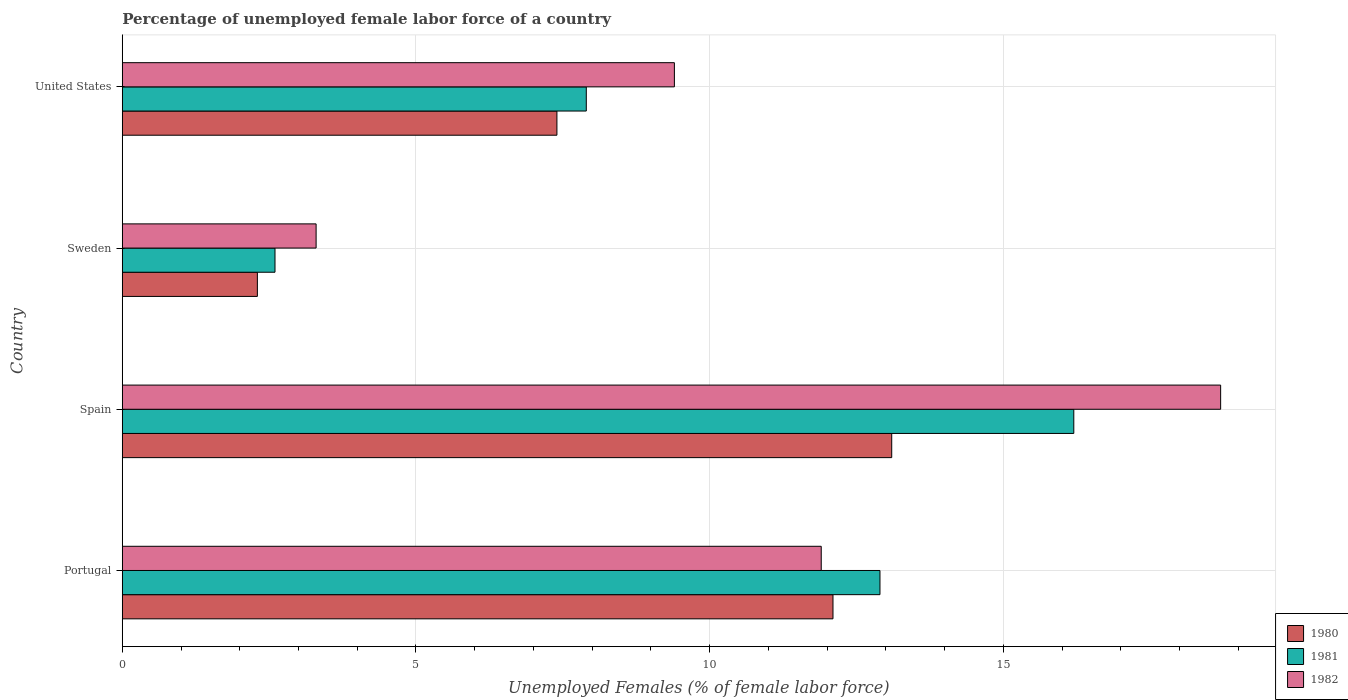Are the number of bars on each tick of the Y-axis equal?
Offer a very short reply. Yes. How many bars are there on the 4th tick from the top?
Ensure brevity in your answer.  3. What is the label of the 3rd group of bars from the top?
Provide a short and direct response. Spain. In how many cases, is the number of bars for a given country not equal to the number of legend labels?
Offer a very short reply. 0. What is the percentage of unemployed female labor force in 1980 in Portugal?
Offer a terse response. 12.1. Across all countries, what is the maximum percentage of unemployed female labor force in 1981?
Ensure brevity in your answer.  16.2. Across all countries, what is the minimum percentage of unemployed female labor force in 1981?
Provide a short and direct response. 2.6. In which country was the percentage of unemployed female labor force in 1980 maximum?
Offer a very short reply. Spain. What is the total percentage of unemployed female labor force in 1980 in the graph?
Your response must be concise. 34.9. What is the difference between the percentage of unemployed female labor force in 1981 in Portugal and that in Sweden?
Keep it short and to the point. 10.3. What is the difference between the percentage of unemployed female labor force in 1981 in Spain and the percentage of unemployed female labor force in 1982 in Portugal?
Keep it short and to the point. 4.3. What is the average percentage of unemployed female labor force in 1982 per country?
Make the answer very short. 10.82. What is the difference between the percentage of unemployed female labor force in 1982 and percentage of unemployed female labor force in 1981 in United States?
Keep it short and to the point. 1.5. What is the ratio of the percentage of unemployed female labor force in 1981 in Portugal to that in United States?
Ensure brevity in your answer.  1.63. What is the difference between the highest and the second highest percentage of unemployed female labor force in 1981?
Offer a very short reply. 3.3. What is the difference between the highest and the lowest percentage of unemployed female labor force in 1981?
Provide a short and direct response. 13.6. In how many countries, is the percentage of unemployed female labor force in 1981 greater than the average percentage of unemployed female labor force in 1981 taken over all countries?
Ensure brevity in your answer.  2. Is it the case that in every country, the sum of the percentage of unemployed female labor force in 1981 and percentage of unemployed female labor force in 1982 is greater than the percentage of unemployed female labor force in 1980?
Provide a succinct answer. Yes. How many bars are there?
Provide a short and direct response. 12. Does the graph contain any zero values?
Provide a succinct answer. No. Does the graph contain grids?
Your response must be concise. Yes. How many legend labels are there?
Give a very brief answer. 3. What is the title of the graph?
Offer a very short reply. Percentage of unemployed female labor force of a country. Does "1969" appear as one of the legend labels in the graph?
Your response must be concise. No. What is the label or title of the X-axis?
Offer a terse response. Unemployed Females (% of female labor force). What is the Unemployed Females (% of female labor force) of 1980 in Portugal?
Keep it short and to the point. 12.1. What is the Unemployed Females (% of female labor force) of 1981 in Portugal?
Your answer should be compact. 12.9. What is the Unemployed Females (% of female labor force) in 1982 in Portugal?
Offer a very short reply. 11.9. What is the Unemployed Females (% of female labor force) of 1980 in Spain?
Keep it short and to the point. 13.1. What is the Unemployed Females (% of female labor force) of 1981 in Spain?
Provide a short and direct response. 16.2. What is the Unemployed Females (% of female labor force) in 1982 in Spain?
Provide a succinct answer. 18.7. What is the Unemployed Females (% of female labor force) of 1980 in Sweden?
Provide a short and direct response. 2.3. What is the Unemployed Females (% of female labor force) of 1981 in Sweden?
Give a very brief answer. 2.6. What is the Unemployed Females (% of female labor force) in 1982 in Sweden?
Your answer should be very brief. 3.3. What is the Unemployed Females (% of female labor force) of 1980 in United States?
Your response must be concise. 7.4. What is the Unemployed Females (% of female labor force) in 1981 in United States?
Make the answer very short. 7.9. What is the Unemployed Females (% of female labor force) in 1982 in United States?
Provide a short and direct response. 9.4. Across all countries, what is the maximum Unemployed Females (% of female labor force) in 1980?
Make the answer very short. 13.1. Across all countries, what is the maximum Unemployed Females (% of female labor force) of 1981?
Give a very brief answer. 16.2. Across all countries, what is the maximum Unemployed Females (% of female labor force) in 1982?
Provide a short and direct response. 18.7. Across all countries, what is the minimum Unemployed Females (% of female labor force) in 1980?
Keep it short and to the point. 2.3. Across all countries, what is the minimum Unemployed Females (% of female labor force) in 1981?
Make the answer very short. 2.6. Across all countries, what is the minimum Unemployed Females (% of female labor force) in 1982?
Offer a very short reply. 3.3. What is the total Unemployed Females (% of female labor force) of 1980 in the graph?
Ensure brevity in your answer.  34.9. What is the total Unemployed Females (% of female labor force) of 1981 in the graph?
Offer a terse response. 39.6. What is the total Unemployed Females (% of female labor force) of 1982 in the graph?
Provide a succinct answer. 43.3. What is the difference between the Unemployed Females (% of female labor force) in 1980 in Portugal and that in Spain?
Your answer should be very brief. -1. What is the difference between the Unemployed Females (% of female labor force) in 1981 in Portugal and that in Spain?
Your answer should be very brief. -3.3. What is the difference between the Unemployed Females (% of female labor force) in 1981 in Portugal and that in Sweden?
Give a very brief answer. 10.3. What is the difference between the Unemployed Females (% of female labor force) of 1980 in Portugal and that in United States?
Make the answer very short. 4.7. What is the difference between the Unemployed Females (% of female labor force) of 1982 in Portugal and that in United States?
Offer a terse response. 2.5. What is the difference between the Unemployed Females (% of female labor force) in 1981 in Spain and that in Sweden?
Your answer should be compact. 13.6. What is the difference between the Unemployed Females (% of female labor force) in 1982 in Spain and that in Sweden?
Keep it short and to the point. 15.4. What is the difference between the Unemployed Females (% of female labor force) in 1980 in Spain and that in United States?
Offer a terse response. 5.7. What is the difference between the Unemployed Females (% of female labor force) in 1980 in Sweden and that in United States?
Ensure brevity in your answer.  -5.1. What is the difference between the Unemployed Females (% of female labor force) in 1980 in Portugal and the Unemployed Females (% of female labor force) in 1981 in Spain?
Ensure brevity in your answer.  -4.1. What is the difference between the Unemployed Females (% of female labor force) in 1980 in Portugal and the Unemployed Females (% of female labor force) in 1982 in Spain?
Give a very brief answer. -6.6. What is the difference between the Unemployed Females (% of female labor force) of 1981 in Portugal and the Unemployed Females (% of female labor force) of 1982 in Spain?
Provide a succinct answer. -5.8. What is the difference between the Unemployed Females (% of female labor force) of 1980 in Portugal and the Unemployed Females (% of female labor force) of 1982 in Sweden?
Offer a very short reply. 8.8. What is the difference between the Unemployed Females (% of female labor force) in 1981 in Portugal and the Unemployed Females (% of female labor force) in 1982 in Sweden?
Ensure brevity in your answer.  9.6. What is the difference between the Unemployed Females (% of female labor force) in 1980 in Portugal and the Unemployed Females (% of female labor force) in 1981 in United States?
Provide a short and direct response. 4.2. What is the difference between the Unemployed Females (% of female labor force) in 1981 in Portugal and the Unemployed Females (% of female labor force) in 1982 in United States?
Give a very brief answer. 3.5. What is the difference between the Unemployed Females (% of female labor force) of 1980 in Spain and the Unemployed Females (% of female labor force) of 1981 in Sweden?
Offer a very short reply. 10.5. What is the difference between the Unemployed Females (% of female labor force) of 1980 in Spain and the Unemployed Females (% of female labor force) of 1982 in Sweden?
Your answer should be compact. 9.8. What is the difference between the Unemployed Females (% of female labor force) in 1981 in Sweden and the Unemployed Females (% of female labor force) in 1982 in United States?
Make the answer very short. -6.8. What is the average Unemployed Females (% of female labor force) of 1980 per country?
Your answer should be very brief. 8.72. What is the average Unemployed Females (% of female labor force) in 1981 per country?
Keep it short and to the point. 9.9. What is the average Unemployed Females (% of female labor force) in 1982 per country?
Ensure brevity in your answer.  10.82. What is the difference between the Unemployed Females (% of female labor force) in 1981 and Unemployed Females (% of female labor force) in 1982 in Portugal?
Your response must be concise. 1. What is the difference between the Unemployed Females (% of female labor force) of 1980 and Unemployed Females (% of female labor force) of 1981 in Spain?
Offer a very short reply. -3.1. What is the difference between the Unemployed Females (% of female labor force) in 1980 and Unemployed Females (% of female labor force) in 1982 in Spain?
Give a very brief answer. -5.6. What is the difference between the Unemployed Females (% of female labor force) in 1980 and Unemployed Females (% of female labor force) in 1981 in Sweden?
Offer a very short reply. -0.3. What is the difference between the Unemployed Females (% of female labor force) in 1980 and Unemployed Females (% of female labor force) in 1982 in Sweden?
Ensure brevity in your answer.  -1. What is the difference between the Unemployed Females (% of female labor force) in 1981 and Unemployed Females (% of female labor force) in 1982 in Sweden?
Your response must be concise. -0.7. What is the difference between the Unemployed Females (% of female labor force) in 1980 and Unemployed Females (% of female labor force) in 1982 in United States?
Offer a very short reply. -2. What is the ratio of the Unemployed Females (% of female labor force) of 1980 in Portugal to that in Spain?
Your answer should be very brief. 0.92. What is the ratio of the Unemployed Females (% of female labor force) in 1981 in Portugal to that in Spain?
Your response must be concise. 0.8. What is the ratio of the Unemployed Females (% of female labor force) in 1982 in Portugal to that in Spain?
Your answer should be compact. 0.64. What is the ratio of the Unemployed Females (% of female labor force) in 1980 in Portugal to that in Sweden?
Keep it short and to the point. 5.26. What is the ratio of the Unemployed Females (% of female labor force) of 1981 in Portugal to that in Sweden?
Make the answer very short. 4.96. What is the ratio of the Unemployed Females (% of female labor force) in 1982 in Portugal to that in Sweden?
Your answer should be compact. 3.61. What is the ratio of the Unemployed Females (% of female labor force) in 1980 in Portugal to that in United States?
Keep it short and to the point. 1.64. What is the ratio of the Unemployed Females (% of female labor force) of 1981 in Portugal to that in United States?
Give a very brief answer. 1.63. What is the ratio of the Unemployed Females (% of female labor force) of 1982 in Portugal to that in United States?
Your answer should be very brief. 1.27. What is the ratio of the Unemployed Females (% of female labor force) in 1980 in Spain to that in Sweden?
Ensure brevity in your answer.  5.7. What is the ratio of the Unemployed Females (% of female labor force) of 1981 in Spain to that in Sweden?
Give a very brief answer. 6.23. What is the ratio of the Unemployed Females (% of female labor force) in 1982 in Spain to that in Sweden?
Provide a short and direct response. 5.67. What is the ratio of the Unemployed Females (% of female labor force) in 1980 in Spain to that in United States?
Give a very brief answer. 1.77. What is the ratio of the Unemployed Females (% of female labor force) in 1981 in Spain to that in United States?
Give a very brief answer. 2.05. What is the ratio of the Unemployed Females (% of female labor force) of 1982 in Spain to that in United States?
Give a very brief answer. 1.99. What is the ratio of the Unemployed Females (% of female labor force) of 1980 in Sweden to that in United States?
Ensure brevity in your answer.  0.31. What is the ratio of the Unemployed Females (% of female labor force) of 1981 in Sweden to that in United States?
Give a very brief answer. 0.33. What is the ratio of the Unemployed Females (% of female labor force) of 1982 in Sweden to that in United States?
Ensure brevity in your answer.  0.35. What is the difference between the highest and the second highest Unemployed Females (% of female labor force) of 1980?
Your response must be concise. 1. What is the difference between the highest and the second highest Unemployed Females (% of female labor force) in 1981?
Offer a terse response. 3.3. What is the difference between the highest and the lowest Unemployed Females (% of female labor force) of 1982?
Offer a terse response. 15.4. 